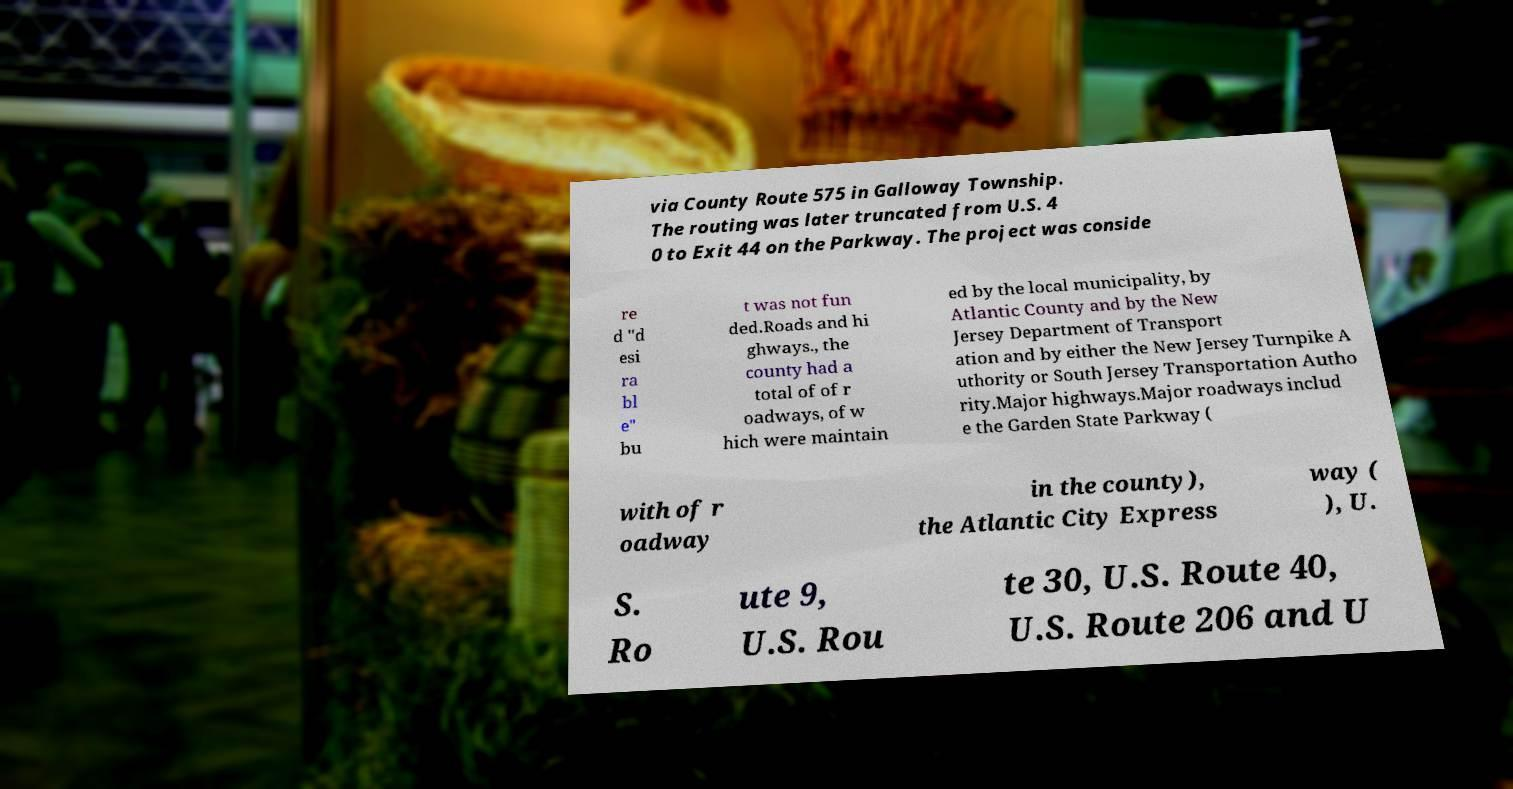There's text embedded in this image that I need extracted. Can you transcribe it verbatim? via County Route 575 in Galloway Township. The routing was later truncated from U.S. 4 0 to Exit 44 on the Parkway. The project was conside re d "d esi ra bl e" bu t was not fun ded.Roads and hi ghways., the county had a total of of r oadways, of w hich were maintain ed by the local municipality, by Atlantic County and by the New Jersey Department of Transport ation and by either the New Jersey Turnpike A uthority or South Jersey Transportation Autho rity.Major highways.Major roadways includ e the Garden State Parkway ( with of r oadway in the county), the Atlantic City Express way ( ), U. S. Ro ute 9, U.S. Rou te 30, U.S. Route 40, U.S. Route 206 and U 